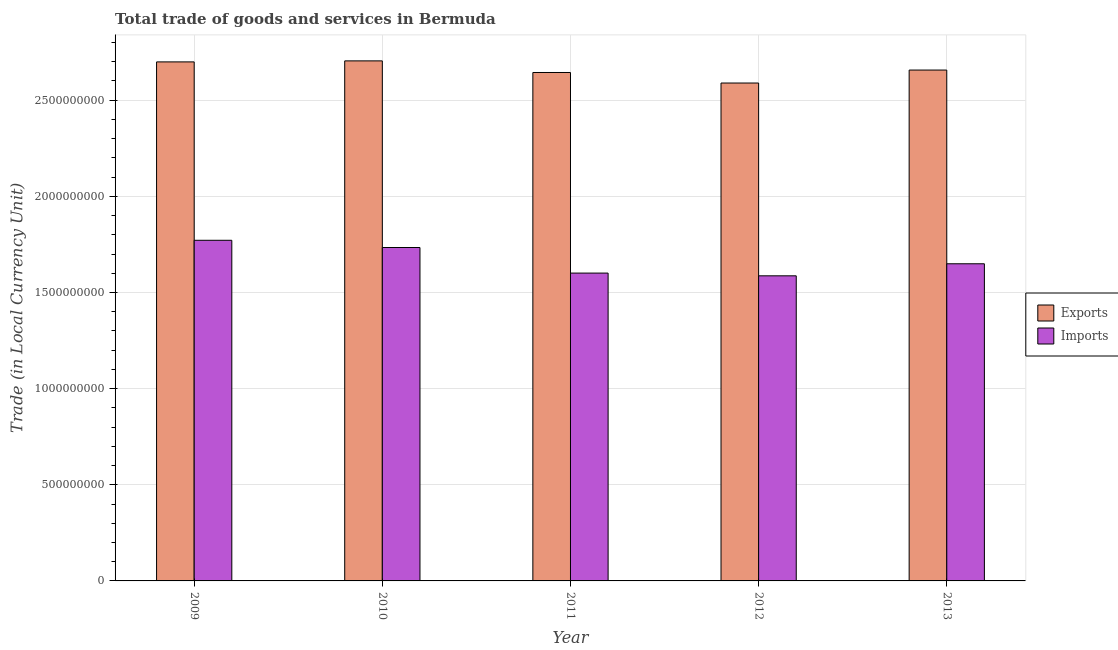How many different coloured bars are there?
Provide a succinct answer. 2. How many groups of bars are there?
Your answer should be compact. 5. Are the number of bars per tick equal to the number of legend labels?
Your response must be concise. Yes. Are the number of bars on each tick of the X-axis equal?
Keep it short and to the point. Yes. How many bars are there on the 2nd tick from the left?
Make the answer very short. 2. How many bars are there on the 4th tick from the right?
Give a very brief answer. 2. What is the imports of goods and services in 2012?
Your response must be concise. 1.59e+09. Across all years, what is the maximum export of goods and services?
Your answer should be compact. 2.70e+09. Across all years, what is the minimum imports of goods and services?
Offer a terse response. 1.59e+09. In which year was the export of goods and services maximum?
Keep it short and to the point. 2010. What is the total imports of goods and services in the graph?
Give a very brief answer. 8.34e+09. What is the difference between the imports of goods and services in 2010 and that in 2013?
Your answer should be compact. 8.46e+07. What is the difference between the imports of goods and services in 2011 and the export of goods and services in 2013?
Provide a short and direct response. -4.84e+07. What is the average export of goods and services per year?
Your answer should be compact. 2.66e+09. In the year 2013, what is the difference between the imports of goods and services and export of goods and services?
Your answer should be compact. 0. In how many years, is the imports of goods and services greater than 100000000 LCU?
Ensure brevity in your answer.  5. What is the ratio of the export of goods and services in 2010 to that in 2011?
Provide a succinct answer. 1.02. Is the export of goods and services in 2009 less than that in 2010?
Provide a short and direct response. Yes. Is the difference between the export of goods and services in 2011 and 2012 greater than the difference between the imports of goods and services in 2011 and 2012?
Your answer should be very brief. No. What is the difference between the highest and the second highest imports of goods and services?
Your answer should be very brief. 3.76e+07. What is the difference between the highest and the lowest export of goods and services?
Ensure brevity in your answer.  1.15e+08. Is the sum of the imports of goods and services in 2010 and 2013 greater than the maximum export of goods and services across all years?
Keep it short and to the point. Yes. What does the 2nd bar from the left in 2013 represents?
Your answer should be compact. Imports. What does the 1st bar from the right in 2013 represents?
Offer a terse response. Imports. How many bars are there?
Your response must be concise. 10. Are all the bars in the graph horizontal?
Keep it short and to the point. No. How many years are there in the graph?
Make the answer very short. 5. Are the values on the major ticks of Y-axis written in scientific E-notation?
Your response must be concise. No. How many legend labels are there?
Your answer should be compact. 2. What is the title of the graph?
Keep it short and to the point. Total trade of goods and services in Bermuda. Does "Research and Development" appear as one of the legend labels in the graph?
Ensure brevity in your answer.  No. What is the label or title of the X-axis?
Offer a very short reply. Year. What is the label or title of the Y-axis?
Offer a very short reply. Trade (in Local Currency Unit). What is the Trade (in Local Currency Unit) in Exports in 2009?
Your answer should be compact. 2.70e+09. What is the Trade (in Local Currency Unit) of Imports in 2009?
Offer a very short reply. 1.77e+09. What is the Trade (in Local Currency Unit) in Exports in 2010?
Give a very brief answer. 2.70e+09. What is the Trade (in Local Currency Unit) of Imports in 2010?
Your answer should be compact. 1.73e+09. What is the Trade (in Local Currency Unit) in Exports in 2011?
Offer a terse response. 2.64e+09. What is the Trade (in Local Currency Unit) in Imports in 2011?
Provide a short and direct response. 1.60e+09. What is the Trade (in Local Currency Unit) in Exports in 2012?
Provide a succinct answer. 2.59e+09. What is the Trade (in Local Currency Unit) of Imports in 2012?
Give a very brief answer. 1.59e+09. What is the Trade (in Local Currency Unit) in Exports in 2013?
Give a very brief answer. 2.66e+09. What is the Trade (in Local Currency Unit) of Imports in 2013?
Provide a short and direct response. 1.65e+09. Across all years, what is the maximum Trade (in Local Currency Unit) of Exports?
Provide a short and direct response. 2.70e+09. Across all years, what is the maximum Trade (in Local Currency Unit) in Imports?
Provide a succinct answer. 1.77e+09. Across all years, what is the minimum Trade (in Local Currency Unit) of Exports?
Your answer should be compact. 2.59e+09. Across all years, what is the minimum Trade (in Local Currency Unit) of Imports?
Your answer should be very brief. 1.59e+09. What is the total Trade (in Local Currency Unit) in Exports in the graph?
Provide a succinct answer. 1.33e+1. What is the total Trade (in Local Currency Unit) of Imports in the graph?
Keep it short and to the point. 8.34e+09. What is the difference between the Trade (in Local Currency Unit) of Exports in 2009 and that in 2010?
Your response must be concise. -5.34e+06. What is the difference between the Trade (in Local Currency Unit) in Imports in 2009 and that in 2010?
Offer a terse response. 3.76e+07. What is the difference between the Trade (in Local Currency Unit) of Exports in 2009 and that in 2011?
Provide a short and direct response. 5.51e+07. What is the difference between the Trade (in Local Currency Unit) in Imports in 2009 and that in 2011?
Offer a very short reply. 1.71e+08. What is the difference between the Trade (in Local Currency Unit) in Exports in 2009 and that in 2012?
Your answer should be compact. 1.10e+08. What is the difference between the Trade (in Local Currency Unit) of Imports in 2009 and that in 2012?
Offer a terse response. 1.85e+08. What is the difference between the Trade (in Local Currency Unit) of Exports in 2009 and that in 2013?
Give a very brief answer. 4.24e+07. What is the difference between the Trade (in Local Currency Unit) of Imports in 2009 and that in 2013?
Make the answer very short. 1.22e+08. What is the difference between the Trade (in Local Currency Unit) in Exports in 2010 and that in 2011?
Offer a terse response. 6.04e+07. What is the difference between the Trade (in Local Currency Unit) of Imports in 2010 and that in 2011?
Make the answer very short. 1.33e+08. What is the difference between the Trade (in Local Currency Unit) in Exports in 2010 and that in 2012?
Keep it short and to the point. 1.15e+08. What is the difference between the Trade (in Local Currency Unit) of Imports in 2010 and that in 2012?
Make the answer very short. 1.47e+08. What is the difference between the Trade (in Local Currency Unit) in Exports in 2010 and that in 2013?
Offer a terse response. 4.78e+07. What is the difference between the Trade (in Local Currency Unit) of Imports in 2010 and that in 2013?
Your answer should be very brief. 8.46e+07. What is the difference between the Trade (in Local Currency Unit) in Exports in 2011 and that in 2012?
Ensure brevity in your answer.  5.48e+07. What is the difference between the Trade (in Local Currency Unit) of Imports in 2011 and that in 2012?
Your answer should be very brief. 1.42e+07. What is the difference between the Trade (in Local Currency Unit) in Exports in 2011 and that in 2013?
Offer a very short reply. -1.27e+07. What is the difference between the Trade (in Local Currency Unit) of Imports in 2011 and that in 2013?
Give a very brief answer. -4.84e+07. What is the difference between the Trade (in Local Currency Unit) in Exports in 2012 and that in 2013?
Offer a terse response. -6.75e+07. What is the difference between the Trade (in Local Currency Unit) in Imports in 2012 and that in 2013?
Your answer should be very brief. -6.26e+07. What is the difference between the Trade (in Local Currency Unit) of Exports in 2009 and the Trade (in Local Currency Unit) of Imports in 2010?
Make the answer very short. 9.65e+08. What is the difference between the Trade (in Local Currency Unit) in Exports in 2009 and the Trade (in Local Currency Unit) in Imports in 2011?
Ensure brevity in your answer.  1.10e+09. What is the difference between the Trade (in Local Currency Unit) of Exports in 2009 and the Trade (in Local Currency Unit) of Imports in 2012?
Keep it short and to the point. 1.11e+09. What is the difference between the Trade (in Local Currency Unit) in Exports in 2009 and the Trade (in Local Currency Unit) in Imports in 2013?
Ensure brevity in your answer.  1.05e+09. What is the difference between the Trade (in Local Currency Unit) in Exports in 2010 and the Trade (in Local Currency Unit) in Imports in 2011?
Your answer should be compact. 1.10e+09. What is the difference between the Trade (in Local Currency Unit) in Exports in 2010 and the Trade (in Local Currency Unit) in Imports in 2012?
Your answer should be very brief. 1.12e+09. What is the difference between the Trade (in Local Currency Unit) of Exports in 2010 and the Trade (in Local Currency Unit) of Imports in 2013?
Keep it short and to the point. 1.06e+09. What is the difference between the Trade (in Local Currency Unit) in Exports in 2011 and the Trade (in Local Currency Unit) in Imports in 2012?
Make the answer very short. 1.06e+09. What is the difference between the Trade (in Local Currency Unit) in Exports in 2011 and the Trade (in Local Currency Unit) in Imports in 2013?
Your answer should be compact. 9.95e+08. What is the difference between the Trade (in Local Currency Unit) of Exports in 2012 and the Trade (in Local Currency Unit) of Imports in 2013?
Make the answer very short. 9.40e+08. What is the average Trade (in Local Currency Unit) in Exports per year?
Make the answer very short. 2.66e+09. What is the average Trade (in Local Currency Unit) in Imports per year?
Your answer should be compact. 1.67e+09. In the year 2009, what is the difference between the Trade (in Local Currency Unit) in Exports and Trade (in Local Currency Unit) in Imports?
Provide a short and direct response. 9.28e+08. In the year 2010, what is the difference between the Trade (in Local Currency Unit) in Exports and Trade (in Local Currency Unit) in Imports?
Give a very brief answer. 9.71e+08. In the year 2011, what is the difference between the Trade (in Local Currency Unit) of Exports and Trade (in Local Currency Unit) of Imports?
Your answer should be compact. 1.04e+09. In the year 2012, what is the difference between the Trade (in Local Currency Unit) of Exports and Trade (in Local Currency Unit) of Imports?
Your response must be concise. 1.00e+09. In the year 2013, what is the difference between the Trade (in Local Currency Unit) in Exports and Trade (in Local Currency Unit) in Imports?
Provide a succinct answer. 1.01e+09. What is the ratio of the Trade (in Local Currency Unit) of Imports in 2009 to that in 2010?
Provide a short and direct response. 1.02. What is the ratio of the Trade (in Local Currency Unit) in Exports in 2009 to that in 2011?
Give a very brief answer. 1.02. What is the ratio of the Trade (in Local Currency Unit) in Imports in 2009 to that in 2011?
Provide a succinct answer. 1.11. What is the ratio of the Trade (in Local Currency Unit) in Exports in 2009 to that in 2012?
Your answer should be compact. 1.04. What is the ratio of the Trade (in Local Currency Unit) of Imports in 2009 to that in 2012?
Provide a succinct answer. 1.12. What is the ratio of the Trade (in Local Currency Unit) of Imports in 2009 to that in 2013?
Your response must be concise. 1.07. What is the ratio of the Trade (in Local Currency Unit) in Exports in 2010 to that in 2011?
Keep it short and to the point. 1.02. What is the ratio of the Trade (in Local Currency Unit) in Imports in 2010 to that in 2011?
Give a very brief answer. 1.08. What is the ratio of the Trade (in Local Currency Unit) in Exports in 2010 to that in 2012?
Make the answer very short. 1.04. What is the ratio of the Trade (in Local Currency Unit) in Imports in 2010 to that in 2012?
Your answer should be very brief. 1.09. What is the ratio of the Trade (in Local Currency Unit) in Imports in 2010 to that in 2013?
Give a very brief answer. 1.05. What is the ratio of the Trade (in Local Currency Unit) in Exports in 2011 to that in 2012?
Give a very brief answer. 1.02. What is the ratio of the Trade (in Local Currency Unit) of Imports in 2011 to that in 2013?
Ensure brevity in your answer.  0.97. What is the ratio of the Trade (in Local Currency Unit) in Exports in 2012 to that in 2013?
Make the answer very short. 0.97. What is the ratio of the Trade (in Local Currency Unit) of Imports in 2012 to that in 2013?
Your answer should be very brief. 0.96. What is the difference between the highest and the second highest Trade (in Local Currency Unit) of Exports?
Give a very brief answer. 5.34e+06. What is the difference between the highest and the second highest Trade (in Local Currency Unit) of Imports?
Offer a very short reply. 3.76e+07. What is the difference between the highest and the lowest Trade (in Local Currency Unit) in Exports?
Your answer should be compact. 1.15e+08. What is the difference between the highest and the lowest Trade (in Local Currency Unit) in Imports?
Provide a succinct answer. 1.85e+08. 